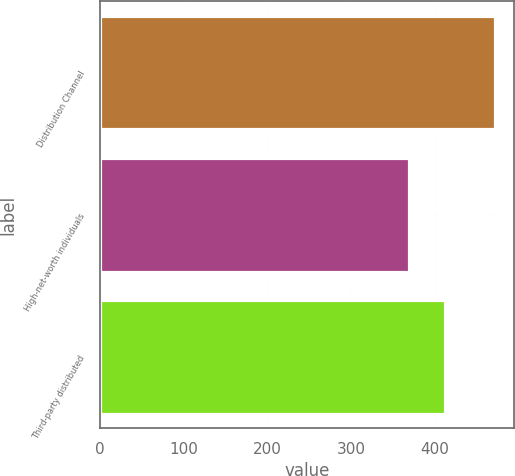Convert chart to OTSL. <chart><loc_0><loc_0><loc_500><loc_500><bar_chart><fcel>Distribution Channel<fcel>High-net-worth individuals<fcel>Third-party distributed<nl><fcel>471<fcel>369<fcel>412<nl></chart> 